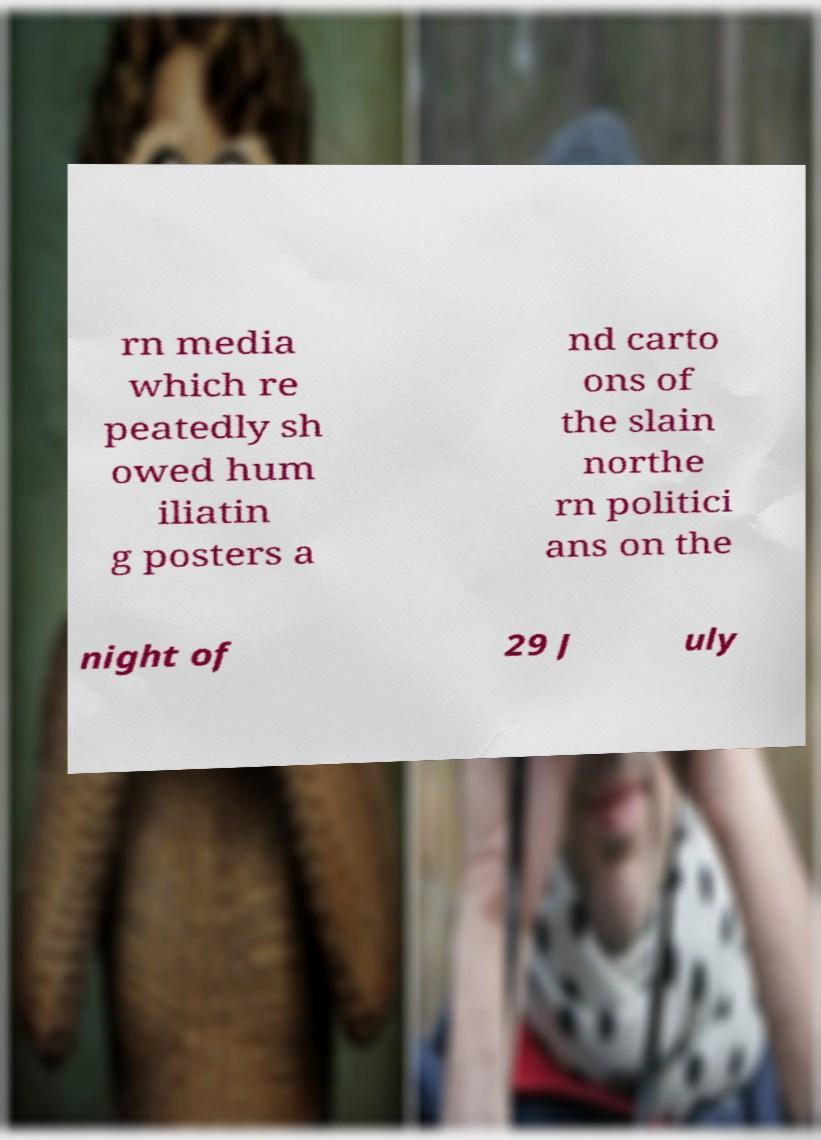Please read and relay the text visible in this image. What does it say? rn media which re peatedly sh owed hum iliatin g posters a nd carto ons of the slain northe rn politici ans on the night of 29 J uly 